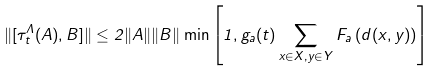Convert formula to latex. <formula><loc_0><loc_0><loc_500><loc_500>\| [ \tau _ { t } ^ { \Lambda } ( A ) , B ] \| \leq 2 \| A \| \| B \| \min \left [ 1 , g _ { a } ( t ) \sum _ { x \in X , y \in Y } F _ { a } \left ( d ( x , y ) \right ) \right ]</formula> 